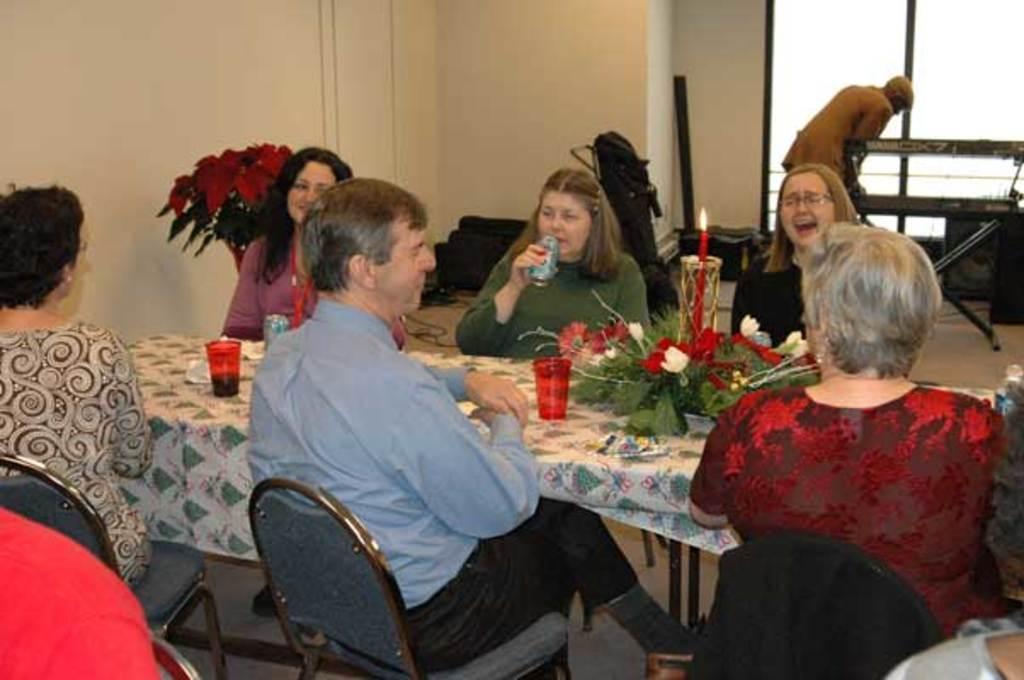In one or two sentences, can you explain what this image depicts? It is a party, there is a table which is of rectangular shape, on the either side of the table there are six people sitting on the table there is a candle,glasses and also some flowers in the background a man is working , there is a cream color wall and a window. 